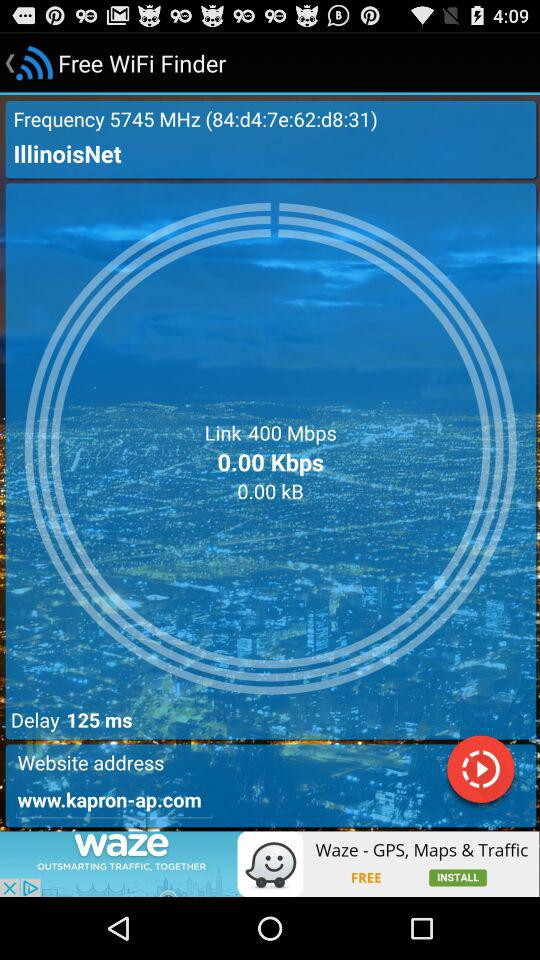What is the frequency? The frequency is 5745 megahertz. 